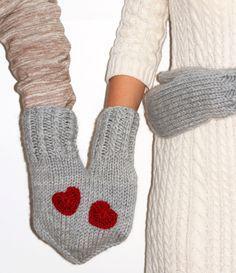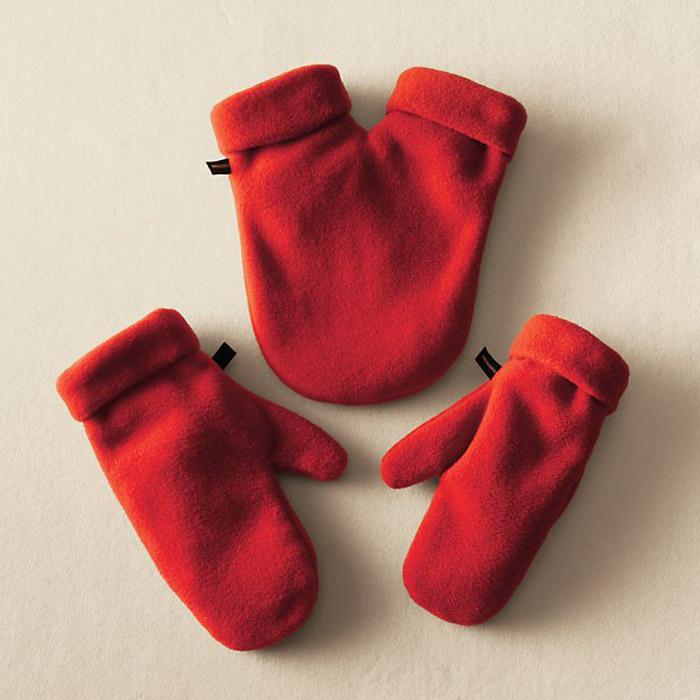The first image is the image on the left, the second image is the image on the right. Evaluate the accuracy of this statement regarding the images: "One of the images shows at least one pair of gloves without any hands in them.". Is it true? Answer yes or no. Yes. The first image is the image on the left, the second image is the image on the right. Considering the images on both sides, is "An image shows a pair of hands in joined red mittens that form a heart shape when worn." valid? Answer yes or no. No. 